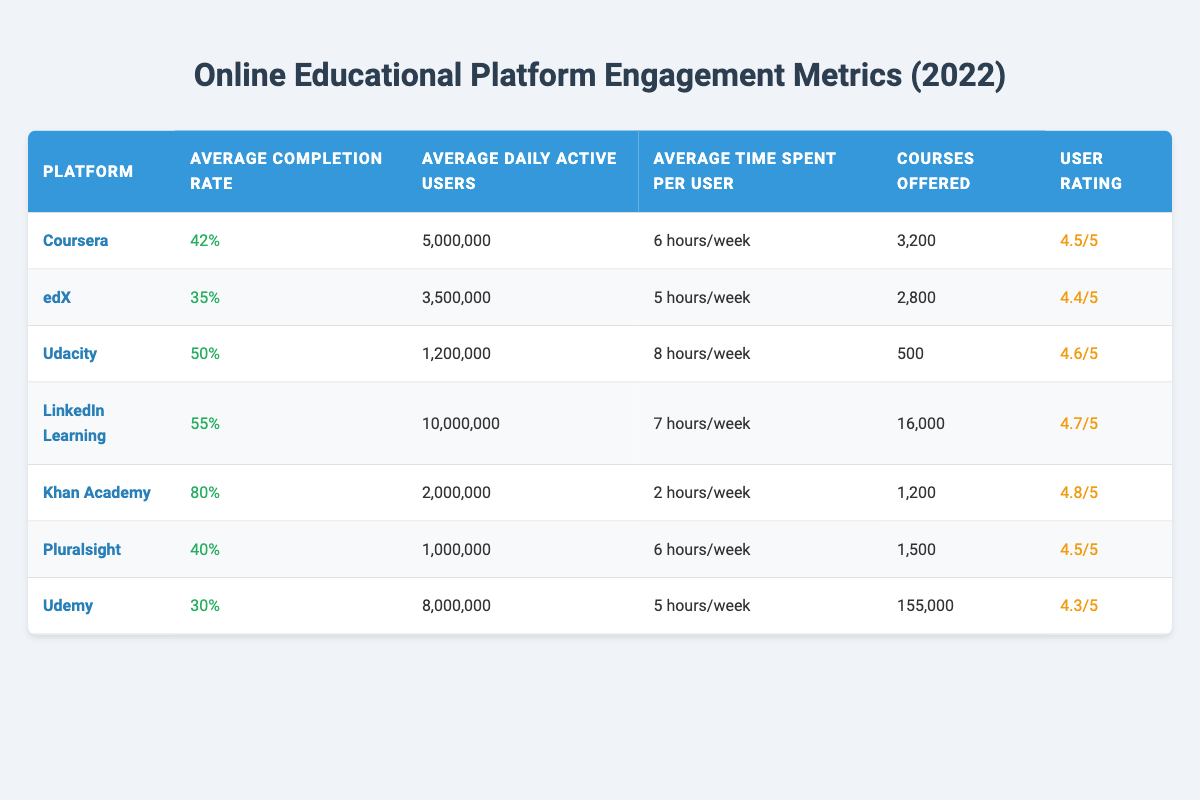What is the average completion rate for the platforms listed? To find the average completion rate, first, add up all the completion rates: 42% + 35% + 50% + 55% + 80% + 40% + 30% = 332%. Then divide by the number of platforms (7): 332% / 7 = 47.43%.
Answer: 47.43% Which platform has the highest number of courses offered? From the table, Udemy offers the most courses at 155,000 followed by LinkedIn Learning with 16,000.
Answer: Udemy What percentage of daily active users does LinkedIn Learning have in comparison to Khan Academy? LinkedIn Learning has 10,000,000 daily active users and Khan Academy has 2,000,000. The difference is 10,000,000 - 2,000,000 = 8,000,000. LinkedIn Learning has 8,000,000 more daily active users than Khan Academy.
Answer: 8,000,000 True or false: Pluralsight has a higher user rating than Udemy. Pluralsight has a user rating of 4.5/5, while Udemy has a user rating of 4.3/5. Therefore, 4.5 is greater than 4.3.
Answer: True Which platform has the lowest average time spent per user per week? Looking at the average time spent per user, Khan Academy has 2 hours/week, which is lower than all other platforms listed.
Answer: Khan Academy How does the average completion rate of Udacity compare to the average of the platforms? Udacity's average completion rate is 50%. Refer to the previous calculation where the average completion rate was found to be 47.43%. To compare, 50% is greater than 47.43%.
Answer: Greater What is the sum of the average daily active users for both edX and Pluralsight? The average daily active users for edX is 3,500,000 and for Pluralsight, it is 1,000,000. Adding these gives 3,500,000 + 1,000,000 = 4,500,000.
Answer: 4,500,000 Which platform has the least engagement based on average completion rate and user rating? The platform with the lowest average completion rate is Udemy at 30%, and it also has the lowest user rating at 4.3/5 among the listed platforms.
Answer: Udemy What is the difference in average time spent per user between Coursera and Udacity? Coursera users spend an average of 6 hours/week while Udacity users spend 8 hours/week. The difference is 8 - 6 = 2 hours.
Answer: 2 hours If we consider the top two platforms by user rating, what are their completion rates? The top two platforms are Khan Academy (4.8/5 rating) and LinkedIn Learning (4.7/5 rating). Their completion rates are 80% and 55%, respectively. Summing gives 80% + 55% = 135%.
Answer: 135% 